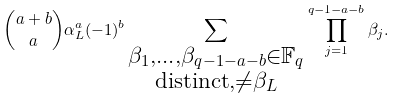<formula> <loc_0><loc_0><loc_500><loc_500>\binom { a + b } { a } \alpha _ { L } ^ { a } ( - 1 ) ^ { b } \sum _ { \substack { \beta _ { 1 } , \dots , \beta _ { q - 1 - a - b } \in \mathbb { F } _ { q } \\ \text {distinct} , \neq \beta _ { L } } } \prod _ { j = 1 } ^ { q - 1 - a - b } \beta _ { j } .</formula> 